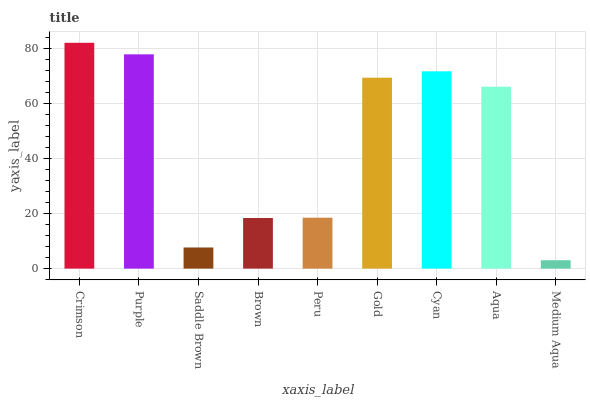Is Medium Aqua the minimum?
Answer yes or no. Yes. Is Crimson the maximum?
Answer yes or no. Yes. Is Purple the minimum?
Answer yes or no. No. Is Purple the maximum?
Answer yes or no. No. Is Crimson greater than Purple?
Answer yes or no. Yes. Is Purple less than Crimson?
Answer yes or no. Yes. Is Purple greater than Crimson?
Answer yes or no. No. Is Crimson less than Purple?
Answer yes or no. No. Is Aqua the high median?
Answer yes or no. Yes. Is Aqua the low median?
Answer yes or no. Yes. Is Saddle Brown the high median?
Answer yes or no. No. Is Saddle Brown the low median?
Answer yes or no. No. 